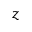Convert formula to latex. <formula><loc_0><loc_0><loc_500><loc_500>z</formula> 